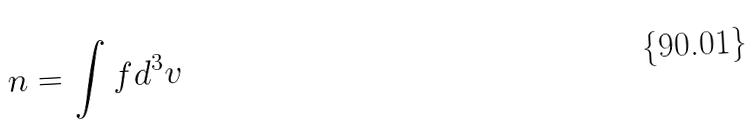Convert formula to latex. <formula><loc_0><loc_0><loc_500><loc_500>n = \int f d ^ { 3 } v</formula> 